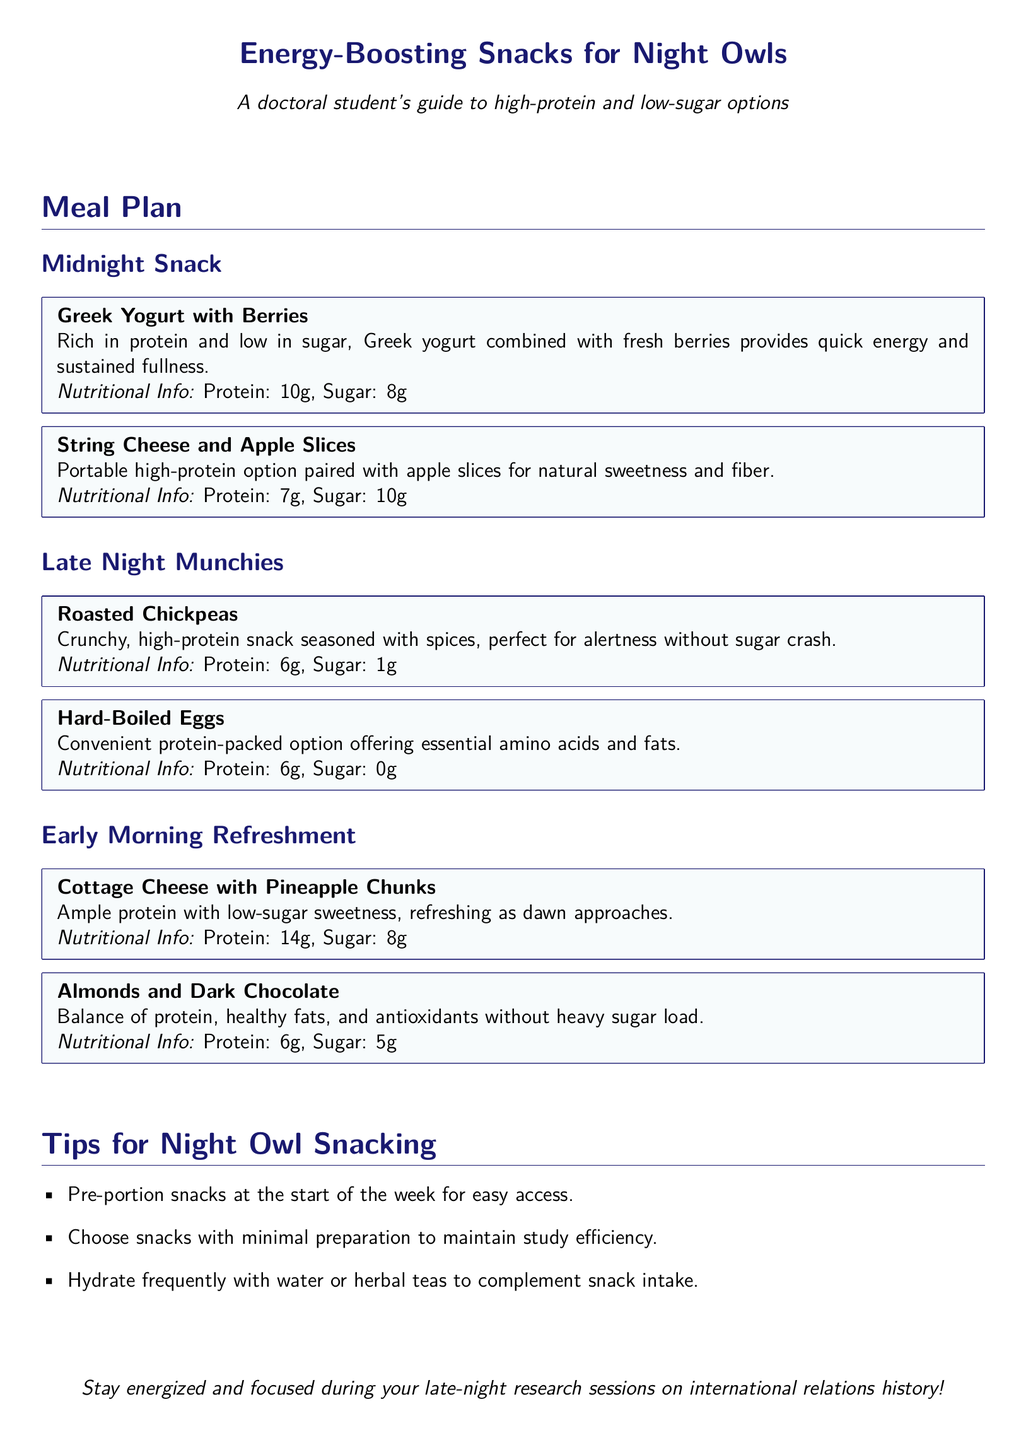What is the first snack listed in the midnight snack section? The first snack listed in the midnight snack section is Greek Yogurt with Berries.
Answer: Greek Yogurt with Berries How much protein is in string cheese and apple slices? The nutritional info for string cheese and apple slices indicates it has 7 grams of protein.
Answer: 7g What type of snack is roasted chickpeas classified as? Roasted chickpeas are classified as a high-protein snack.
Answer: High-protein What is the sugar content of hard-boiled eggs? The nutritional info specifies that hard-boiled eggs contain 0 grams of sugar.
Answer: 0g Which snack has the highest protein content in the early morning refreshment section? The snack with the highest protein content in that section is Cottage Cheese with Pineapple Chunks.
Answer: Cottage Cheese with Pineapple Chunks What is a recommended tip for night owl snacking? One of the tips suggests pre-portioning snacks at the start of the week.
Answer: Pre-portion snacks How many grams of sugar are in almonds and dark chocolate? The nutritional info states that almonds and dark chocolate contain 5 grams of sugar.
Answer: 5g Which snack is suggested as refreshment as dawn approaches? Cottage Cheese with Pineapple Chunks is suggested as a refreshing snack as dawn approaches.
Answer: Cottage Cheese with Pineapple Chunks What color is used for the title in the document? The color used for the title is midnight.
Answer: Midnight 